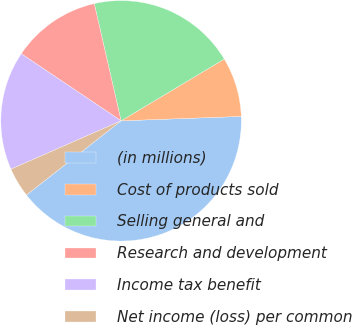<chart> <loc_0><loc_0><loc_500><loc_500><pie_chart><fcel>(in millions)<fcel>Cost of products sold<fcel>Selling general and<fcel>Research and development<fcel>Income tax benefit<fcel>Net income (loss) per common<nl><fcel>40.0%<fcel>8.0%<fcel>20.0%<fcel>12.0%<fcel>16.0%<fcel>4.0%<nl></chart> 